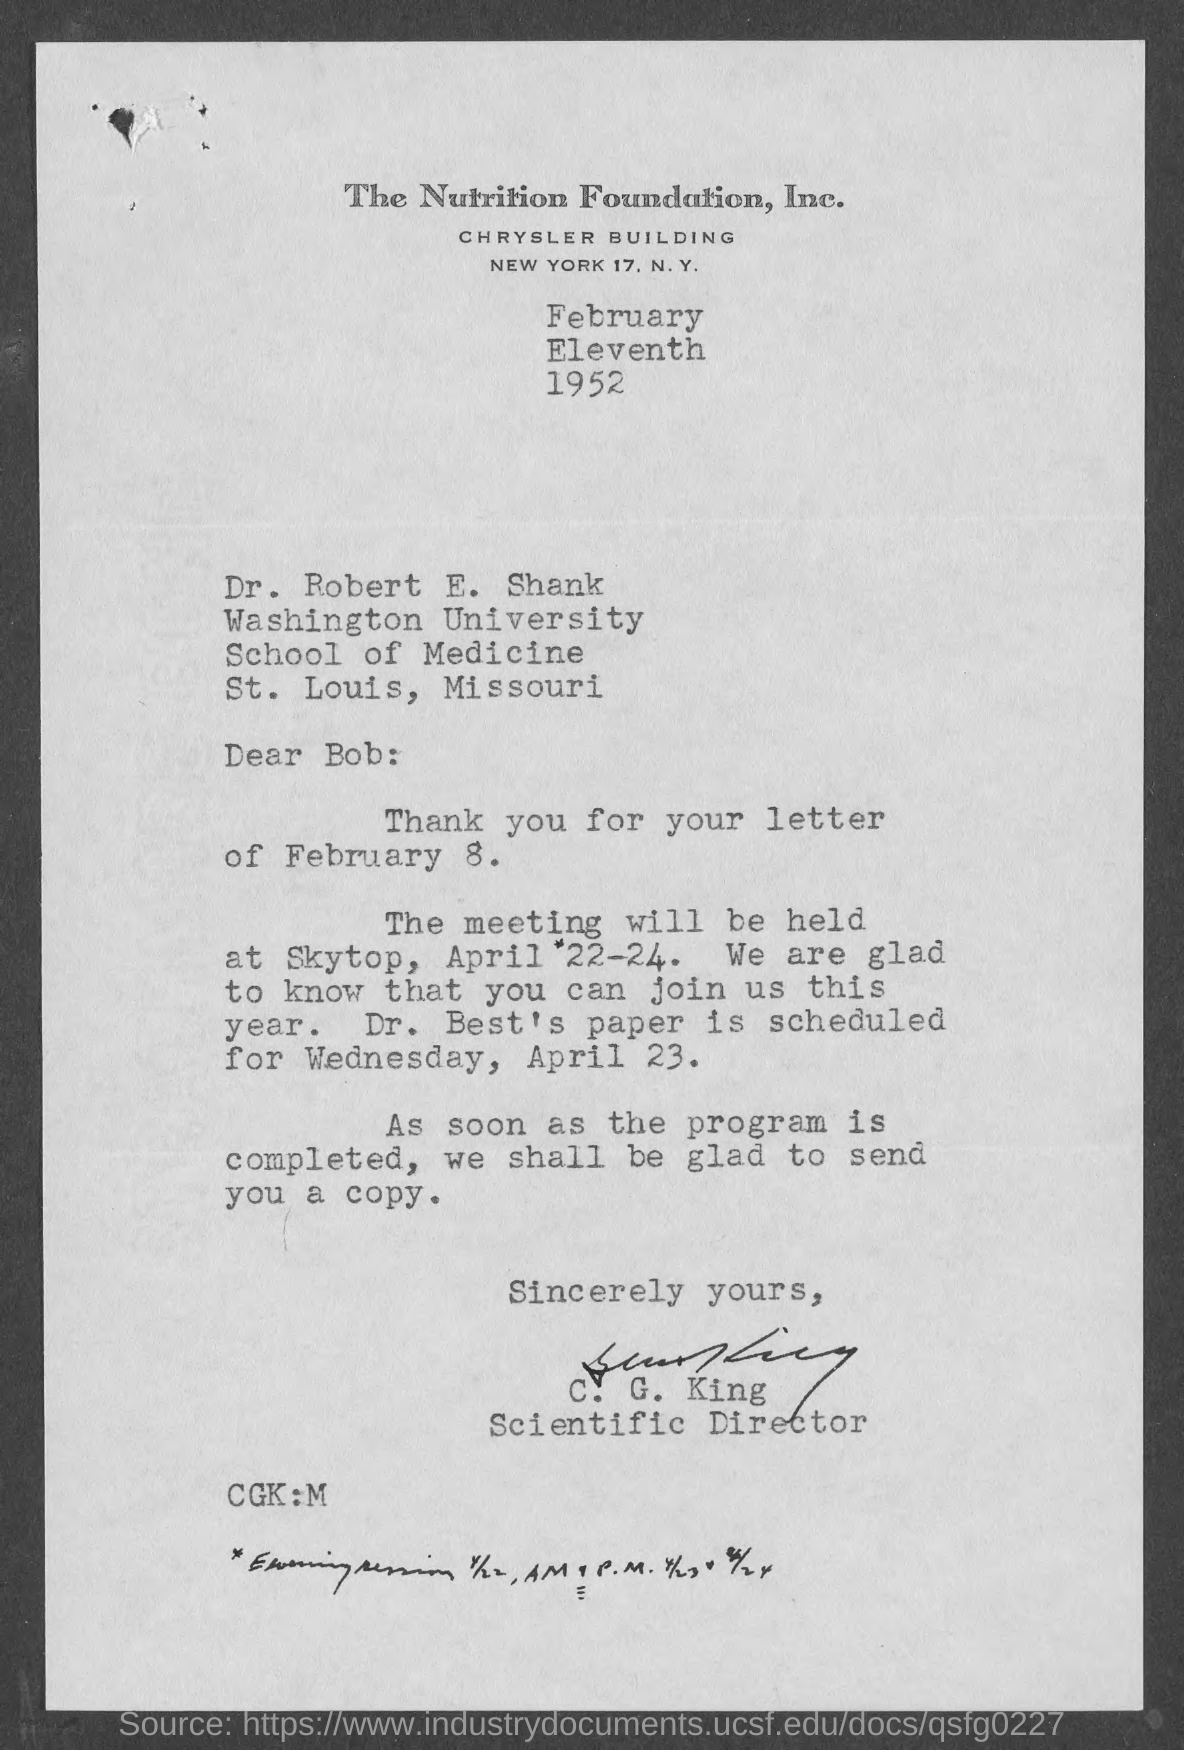Mention a couple of crucial points in this snapshot. Dr. Best's paper is scheduled to be presented on Wednesday, April 23rd. C. G. King holds the title of Scientific Director. The meeting will be held on April 22-24. The letter is addressed to Dr. Robert E. Shank. The meeting will be held at Skytop. 